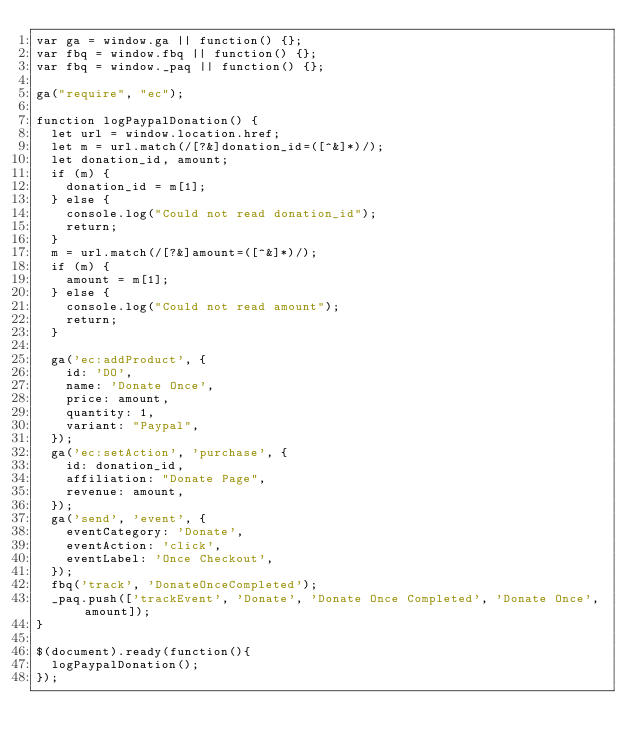<code> <loc_0><loc_0><loc_500><loc_500><_JavaScript_>var ga = window.ga || function() {};
var fbq = window.fbq || function() {};
var fbq = window._paq || function() {};

ga("require", "ec");

function logPaypalDonation() {
  let url = window.location.href;
  let m = url.match(/[?&]donation_id=([^&]*)/);
  let donation_id, amount;
  if (m) {
    donation_id = m[1];
  } else {
    console.log("Could not read donation_id");
    return;
  }
  m = url.match(/[?&]amount=([^&]*)/);
  if (m) {
    amount = m[1];
  } else {
    console.log("Could not read amount");
    return;
  }

  ga('ec:addProduct', {
    id: 'DO',
    name: 'Donate Once',
    price: amount,
    quantity: 1,
    variant: "Paypal",
  });
  ga('ec:setAction', 'purchase', {
    id: donation_id,
    affiliation: "Donate Page",
    revenue: amount,
  });
  ga('send', 'event', {
    eventCategory: 'Donate',
    eventAction: 'click',
    eventLabel: 'Once Checkout',
  });
  fbq('track', 'DonateOnceCompleted');
  _paq.push(['trackEvent', 'Donate', 'Donate Once Completed', 'Donate Once', amount]);
}

$(document).ready(function(){
  logPaypalDonation();
});

</code> 